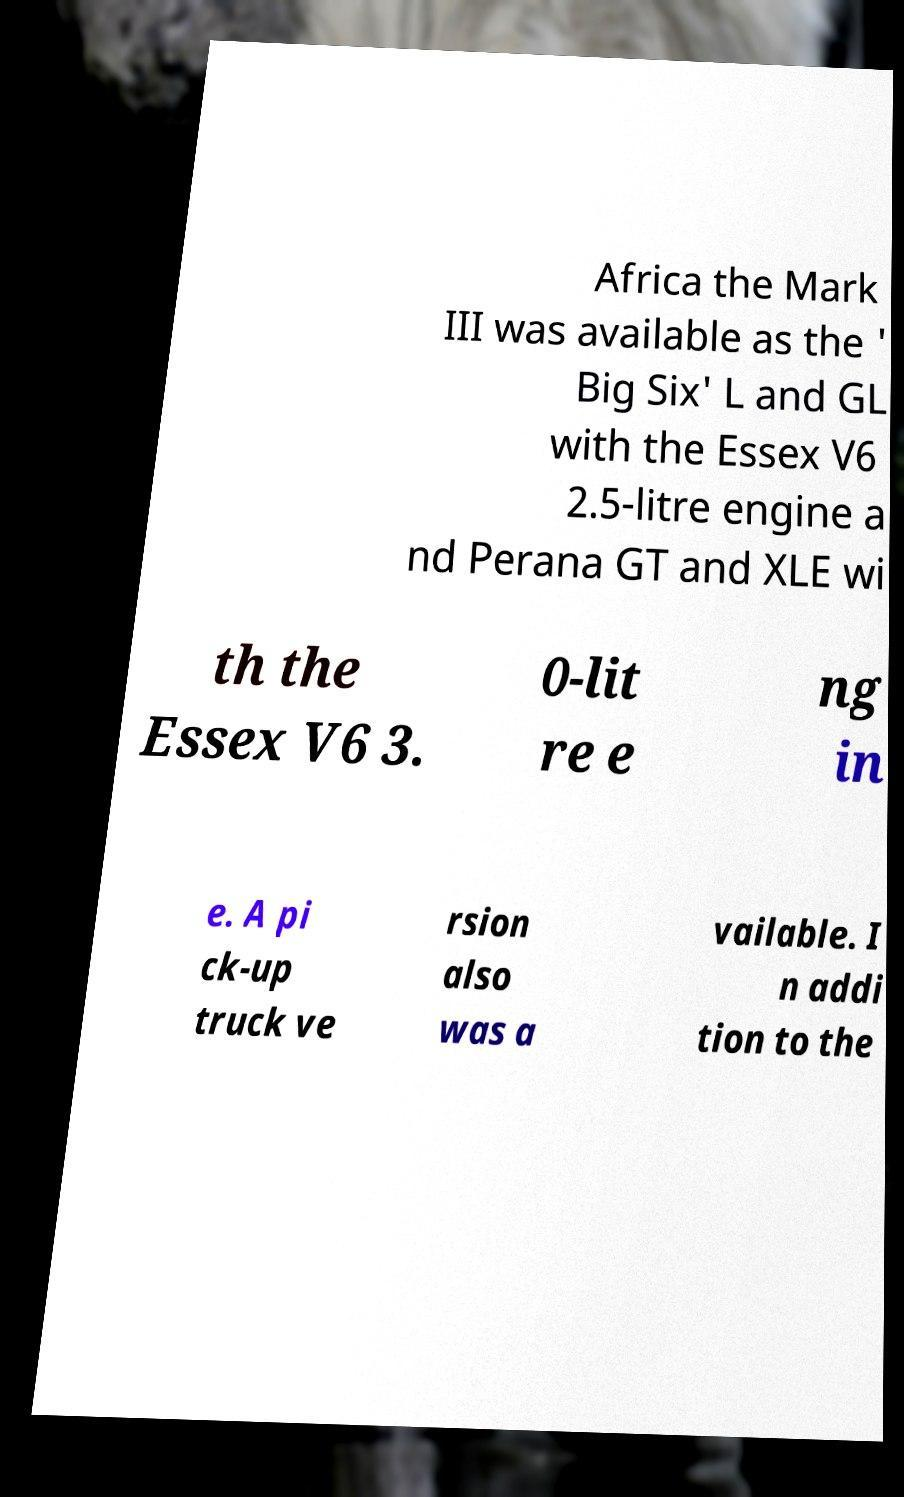There's text embedded in this image that I need extracted. Can you transcribe it verbatim? Africa the Mark III was available as the ' Big Six' L and GL with the Essex V6 2.5-litre engine a nd Perana GT and XLE wi th the Essex V6 3. 0-lit re e ng in e. A pi ck-up truck ve rsion also was a vailable. I n addi tion to the 